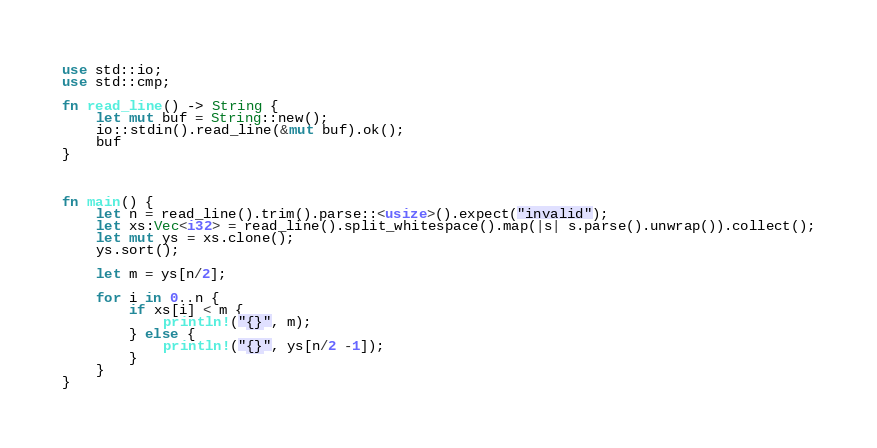Convert code to text. <code><loc_0><loc_0><loc_500><loc_500><_Rust_>use std::io;
use std::cmp;

fn read_line() -> String {
    let mut buf = String::new();
    io::stdin().read_line(&mut buf).ok();
    buf
}



fn main() {
    let n = read_line().trim().parse::<usize>().expect("invalid");
    let xs:Vec<i32> = read_line().split_whitespace().map(|s| s.parse().unwrap()).collect();
    let mut ys = xs.clone();
    ys.sort();
    
    let m = ys[n/2];

    for i in 0..n {
        if xs[i] < m {
            println!("{}", m);
        } else {
            println!("{}", ys[n/2 -1]);
        }
    }
}
</code> 